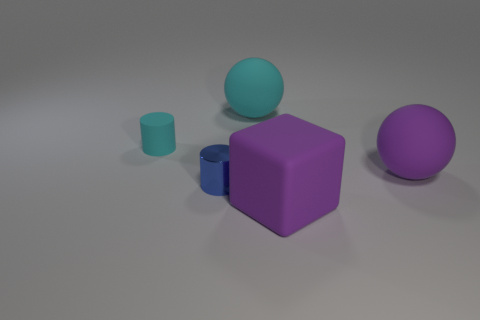Is there any other thing that is the same material as the blue cylinder?
Ensure brevity in your answer.  No. Does the small object in front of the tiny rubber object have the same color as the big rubber ball in front of the small cyan matte cylinder?
Ensure brevity in your answer.  No. What is the shape of the purple matte object that is the same size as the purple ball?
Ensure brevity in your answer.  Cube. How many things are either big purple rubber things behind the rubber cube or purple objects on the right side of the large purple cube?
Ensure brevity in your answer.  1. Is the number of gray rubber spheres less than the number of metallic cylinders?
Keep it short and to the point. Yes. There is a blue object that is the same size as the cyan cylinder; what is its material?
Give a very brief answer. Metal. There is a rubber thing in front of the shiny object; is its size the same as the ball in front of the big cyan matte thing?
Ensure brevity in your answer.  Yes. Is there another cyan thing that has the same material as the large cyan thing?
Keep it short and to the point. Yes. How many objects are cylinders in front of the small cyan object or big cyan spheres?
Ensure brevity in your answer.  2. Do the big sphere on the right side of the cyan sphere and the cyan cylinder have the same material?
Provide a short and direct response. Yes. 